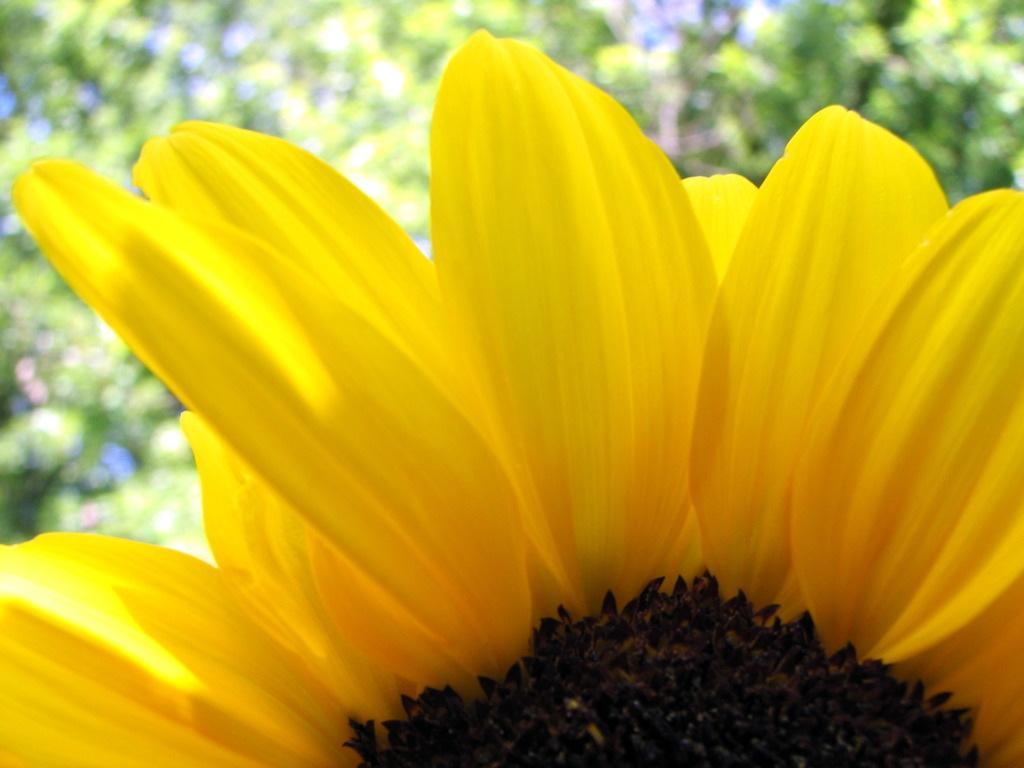In one or two sentences, can you explain what this image depicts? In this picture, we can see a yellow flower and behind the flower there are blurred things. 